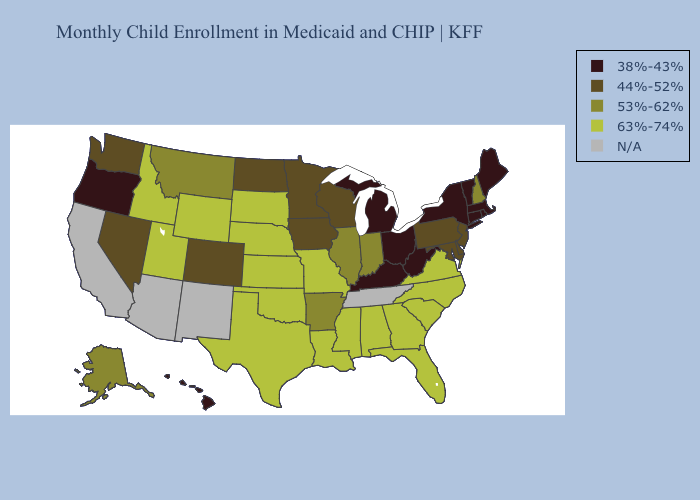Name the states that have a value in the range 53%-62%?
Answer briefly. Alaska, Arkansas, Illinois, Indiana, Montana, New Hampshire. What is the highest value in states that border Georgia?
Keep it brief. 63%-74%. What is the lowest value in the Northeast?
Write a very short answer. 38%-43%. Name the states that have a value in the range 63%-74%?
Give a very brief answer. Alabama, Florida, Georgia, Idaho, Kansas, Louisiana, Mississippi, Missouri, Nebraska, North Carolina, Oklahoma, South Carolina, South Dakota, Texas, Utah, Virginia, Wyoming. Name the states that have a value in the range 44%-52%?
Short answer required. Colorado, Delaware, Iowa, Maryland, Minnesota, Nevada, New Jersey, North Dakota, Pennsylvania, Washington, Wisconsin. Does the map have missing data?
Keep it brief. Yes. How many symbols are there in the legend?
Keep it brief. 5. Does the first symbol in the legend represent the smallest category?
Quick response, please. Yes. Which states have the lowest value in the USA?
Be succinct. Connecticut, Hawaii, Kentucky, Maine, Massachusetts, Michigan, New York, Ohio, Oregon, Rhode Island, Vermont, West Virginia. Is the legend a continuous bar?
Write a very short answer. No. Name the states that have a value in the range N/A?
Write a very short answer. Arizona, California, New Mexico, Tennessee. Among the states that border Minnesota , does Wisconsin have the lowest value?
Be succinct. Yes. Which states hav the highest value in the Northeast?
Give a very brief answer. New Hampshire. Name the states that have a value in the range 44%-52%?
Write a very short answer. Colorado, Delaware, Iowa, Maryland, Minnesota, Nevada, New Jersey, North Dakota, Pennsylvania, Washington, Wisconsin. 